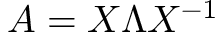Convert formula to latex. <formula><loc_0><loc_0><loc_500><loc_500>A = X \Lambda X ^ { - 1 }</formula> 